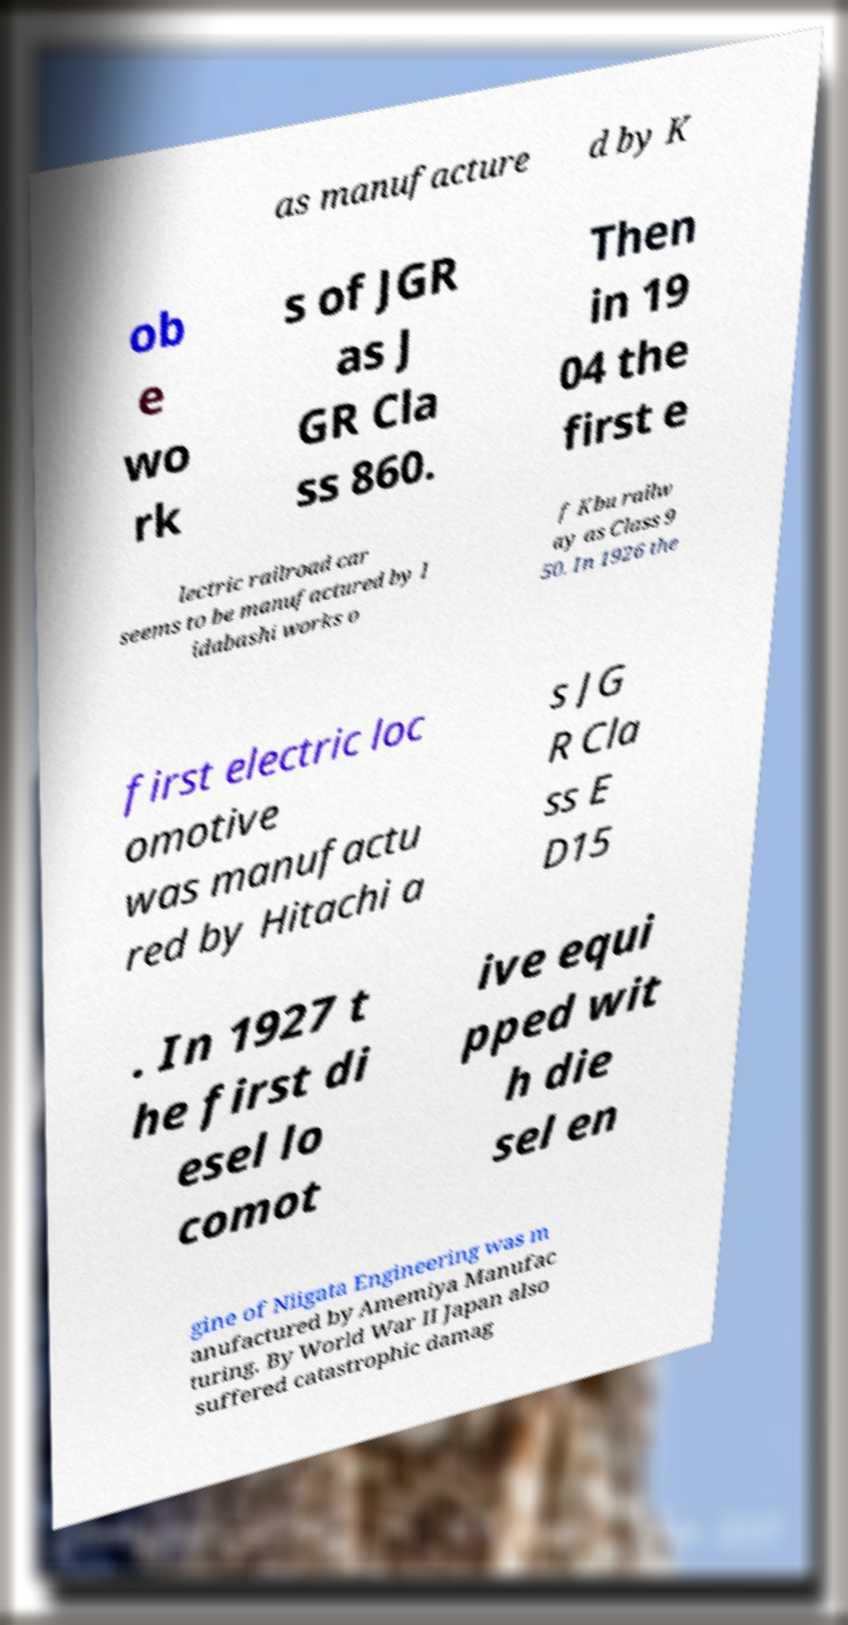Can you read and provide the text displayed in the image?This photo seems to have some interesting text. Can you extract and type it out for me? as manufacture d by K ob e wo rk s of JGR as J GR Cla ss 860. Then in 19 04 the first e lectric railroad car seems to be manufactured by I idabashi works o f Kbu railw ay as Class 9 50. In 1926 the first electric loc omotive was manufactu red by Hitachi a s JG R Cla ss E D15 . In 1927 t he first di esel lo comot ive equi pped wit h die sel en gine of Niigata Engineering was m anufactured by Amemiya Manufac turing. By World War II Japan also suffered catastrophic damag 